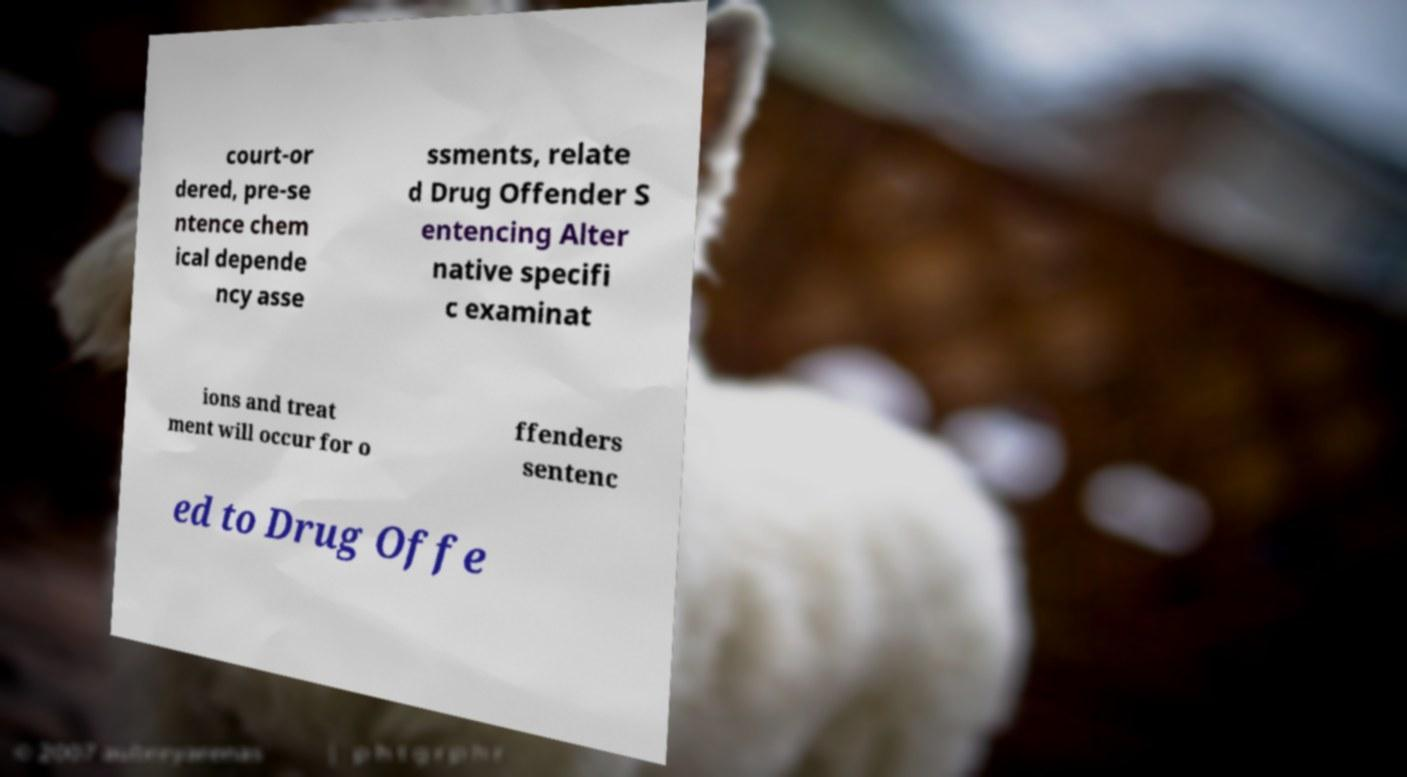Please read and relay the text visible in this image. What does it say? court-or dered, pre-se ntence chem ical depende ncy asse ssments, relate d Drug Offender S entencing Alter native specifi c examinat ions and treat ment will occur for o ffenders sentenc ed to Drug Offe 